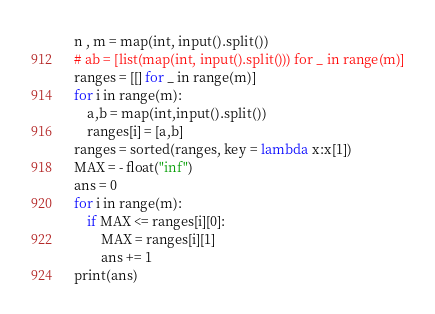<code> <loc_0><loc_0><loc_500><loc_500><_Python_>n , m = map(int, input().split())
# ab = [list(map(int, input().split())) for _ in range(m)]
ranges = [[] for _ in range(m)]
for i in range(m):
    a,b = map(int,input().split())
    ranges[i] = [a,b]
ranges = sorted(ranges, key = lambda x:x[1])
MAX = - float("inf")
ans = 0
for i in range(m):
    if MAX <= ranges[i][0]:
        MAX = ranges[i][1]
        ans += 1
print(ans)</code> 